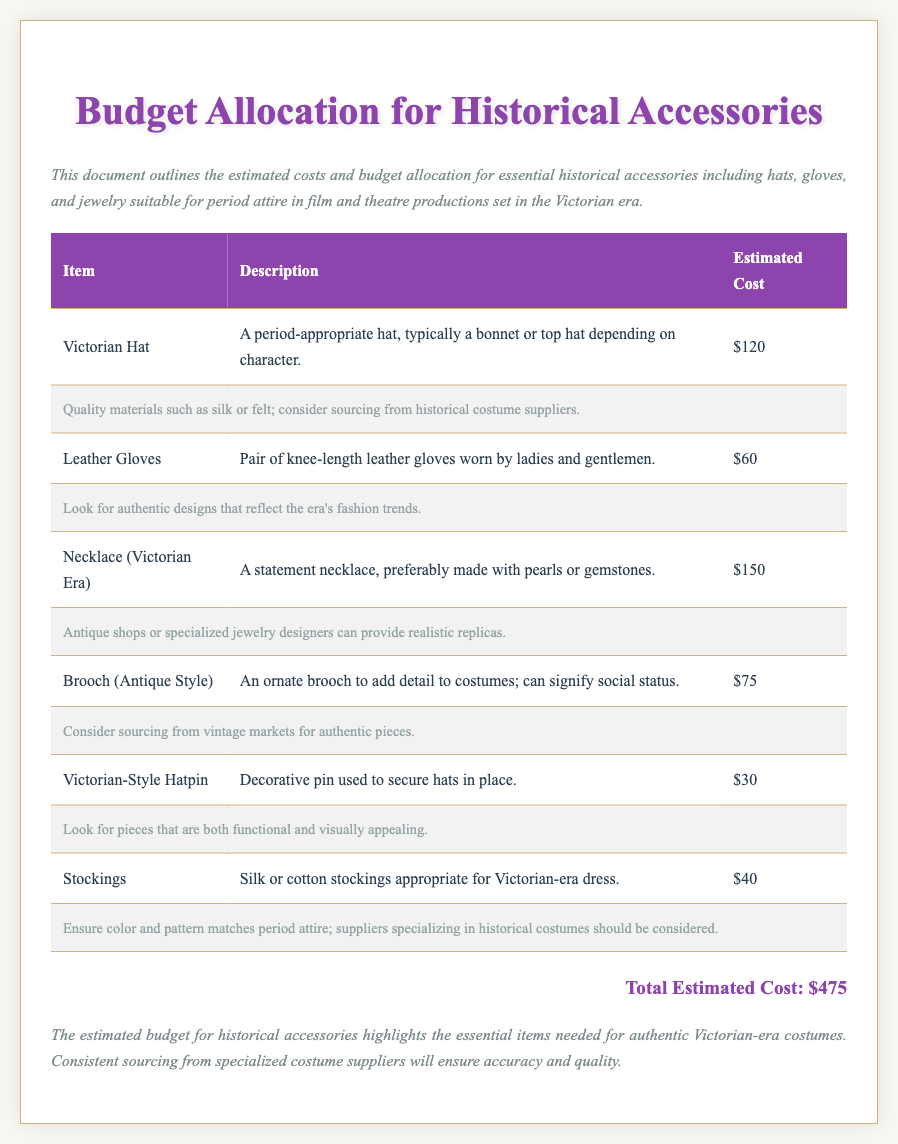What is the total estimated cost? The total estimated cost is listed at the bottom of the document and sums the individual costs of all accessories, which is $475.
Answer: $475 How much does a Victorian hat cost? The cost of a Victorian hat is specified in the table under "Estimated Cost," which states that it is $120.
Answer: $120 What type of jewelry is mentioned in the budget? The budget specifically includes a Victorian-era necklace as one of the historical accessories listed.
Answer: Necklace What is the cost of leather gloves? The cost is provided in the table, where it indicates that a pair of leather gloves costs $60.
Answer: $60 How many types of accessories are listed in the budget? By counting the items in the table, there are six types of accessories outlined in the document.
Answer: Six What kind of materials should be used for the Victorian hat? The document notes that quality materials such as silk or felt should be used for crafting a Victorian hat.
Answer: Silk or felt Which item signifies social status according to the document? The document indicates that the ornate brooch can signify social status as part of the attire.
Answer: Brooch What sourcing options are suggested for jewelry? The document suggests sourcing jewelry from antique shops or specialized jewelry designers.
Answer: Antique shops or specialized jewelry designers What type of gloves are included in the accessories budget? The document specifies that the gloves included are leather gloves worn by both ladies and gentlemen.
Answer: Leather gloves 